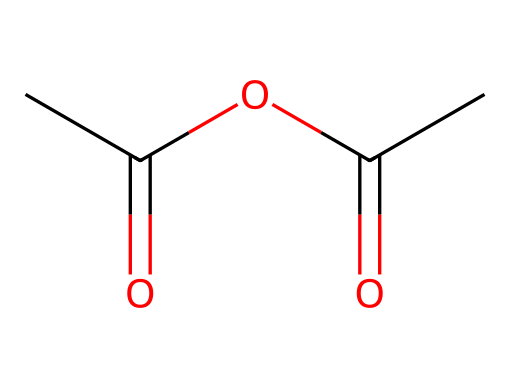What is the molecular formula of acetic anhydride? The SMILES representation indicates there are 4 carbon atoms (C), 6 hydrogen atoms (H), and 3 oxygen atoms (O) based on the structure. Thus, the molecular formula can be derived as C4H6O3.
Answer: C4H6O3 How many carbon atoms are in acetic anhydride? By analyzing the SMILES string, there are four distinct carbon atoms present in the structure.
Answer: 4 What type of functional groups are present in acetic anhydride? The structure showcases two acyl (carbonyl) groups (C=O) and one ester link (C-O-C). This indicates an anhydride formation with carbonyl functionalities.
Answer: acyl and ester What is the overall hybridization of the central carbon atom in acetic anhydride? The central carbon, which is part of the carbonyl groups, is connected to both a carbon atom and an oxygen atom. This implies it is involved in double bonds due to the two carbonyls presenting sp2 hybridization.
Answer: sp2 How many double bonds are present in acetic anhydride? From the structural analysis indicated in the SMILES, there are two double bonds (the two C=O carbonyl groups) associated with the structure.
Answer: 2 What type of acid anhydride is acetic anhydride classified as? Since acetic anhydride is derived from acetic acid, it is classified as a symmetrical acid anhydride. It is formed from the removal of water from two acetic acid molecules.
Answer: symmetrical 